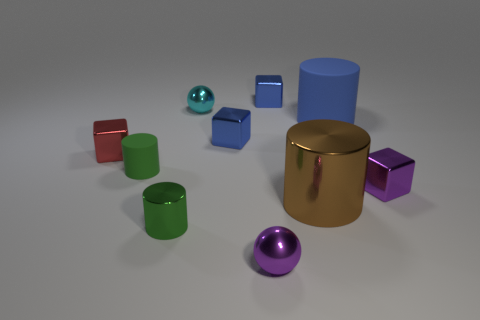Subtract all cylinders. How many objects are left? 6 Add 9 red objects. How many red objects exist? 10 Subtract 0 blue spheres. How many objects are left? 10 Subtract all large blue objects. Subtract all big metallic cylinders. How many objects are left? 8 Add 3 small green rubber cylinders. How many small green rubber cylinders are left? 4 